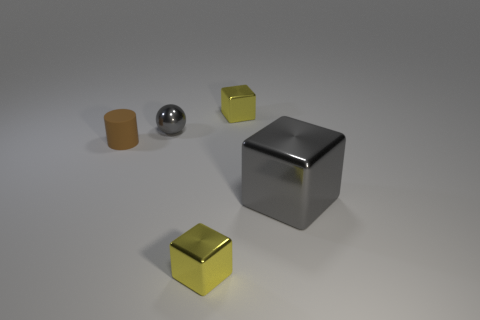Is there anything else that is made of the same material as the small brown object?
Offer a very short reply. No. There is a big object that is the same color as the small metallic sphere; what shape is it?
Your answer should be very brief. Cube. There is a gray object that is behind the gray block; is its size the same as the brown matte cylinder?
Provide a succinct answer. Yes. What is the shape of the tiny gray object?
Provide a short and direct response. Sphere. What number of other matte things have the same shape as the brown rubber thing?
Your answer should be very brief. 0. What number of metallic objects are on the right side of the gray metallic ball and on the left side of the gray block?
Offer a terse response. 2. What color is the ball?
Provide a short and direct response. Gray. Are there any large green cylinders that have the same material as the small gray sphere?
Keep it short and to the point. No. There is a gray metal object on the right side of the yellow shiny cube that is in front of the small gray thing; are there any big shiny objects in front of it?
Your answer should be very brief. No. Are there any tiny yellow metal blocks to the left of the small brown rubber object?
Your answer should be very brief. No. 